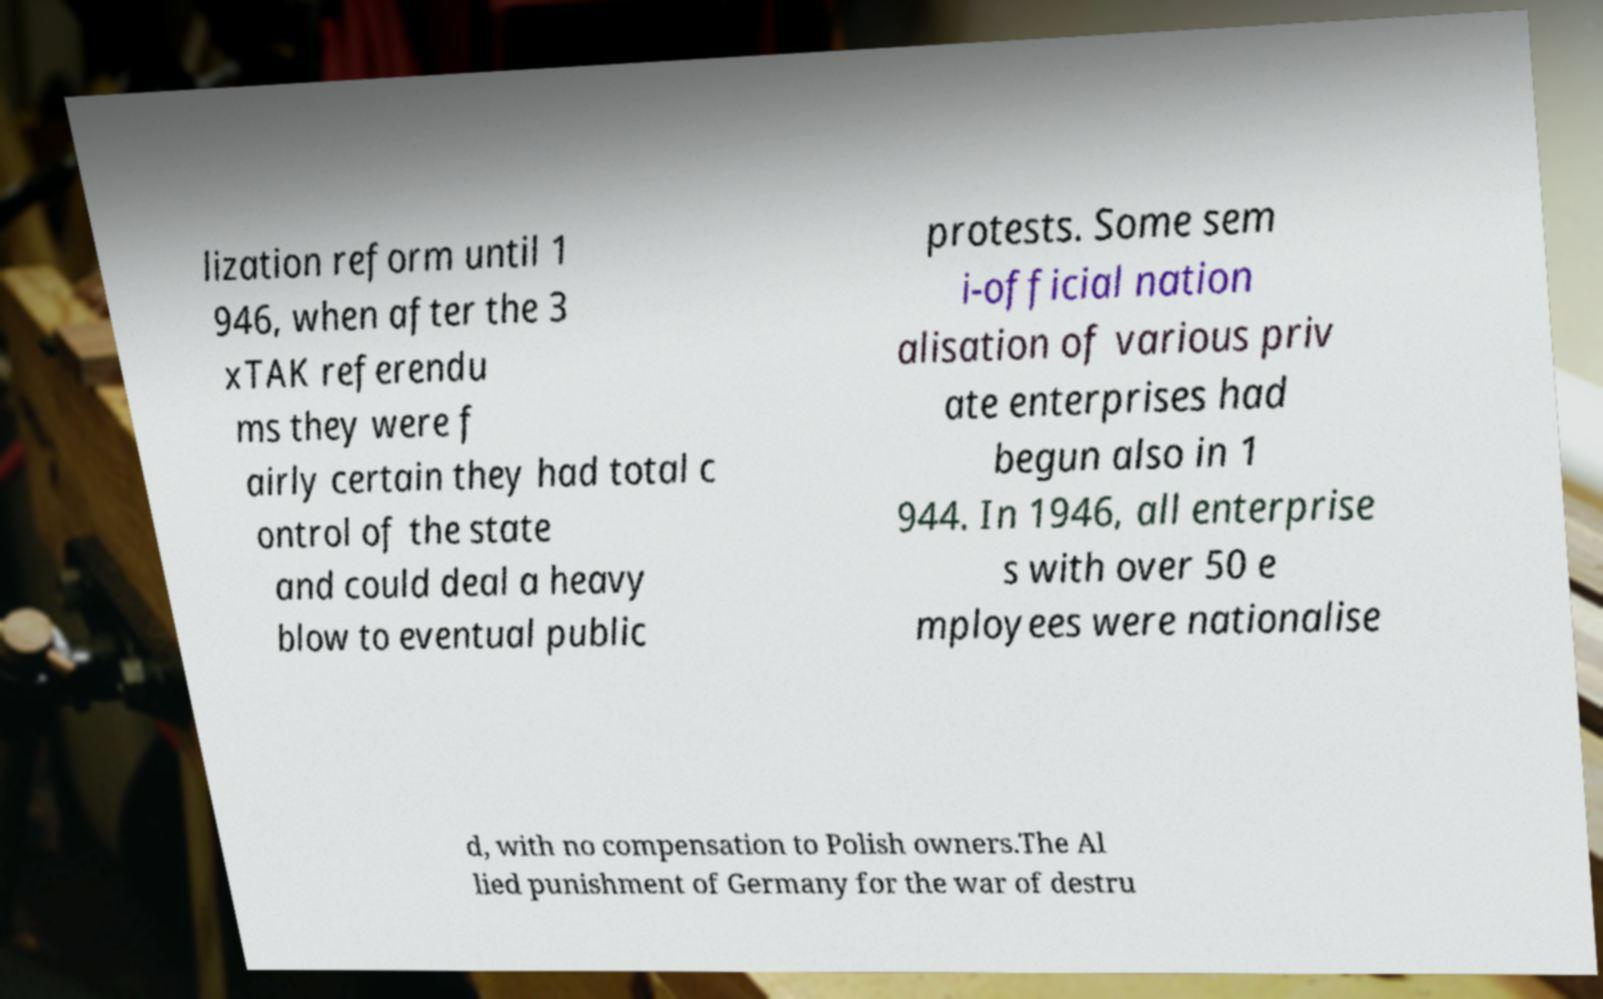Please read and relay the text visible in this image. What does it say? lization reform until 1 946, when after the 3 xTAK referendu ms they were f airly certain they had total c ontrol of the state and could deal a heavy blow to eventual public protests. Some sem i-official nation alisation of various priv ate enterprises had begun also in 1 944. In 1946, all enterprise s with over 50 e mployees were nationalise d, with no compensation to Polish owners.The Al lied punishment of Germany for the war of destru 